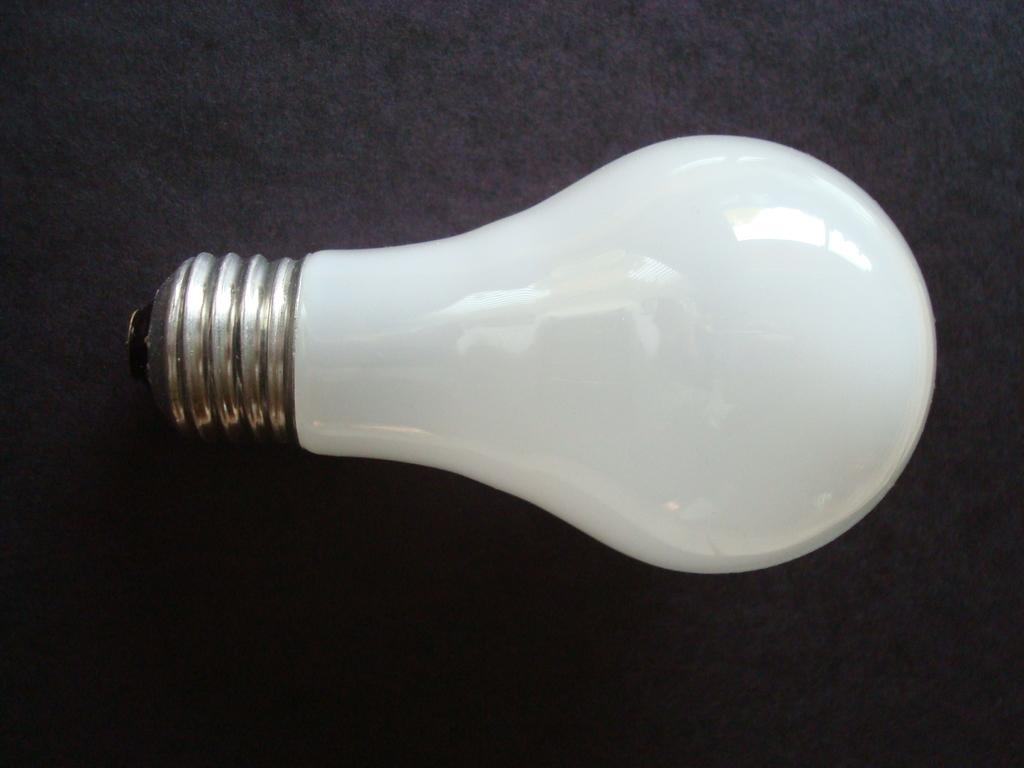What object is present in the image? There is a bulb in the image. Where is the bulb located? The bulb is placed on a surface. What type of mountain is visible in the image? There is no mountain present in the image; it only features a bulb placed on a surface. 